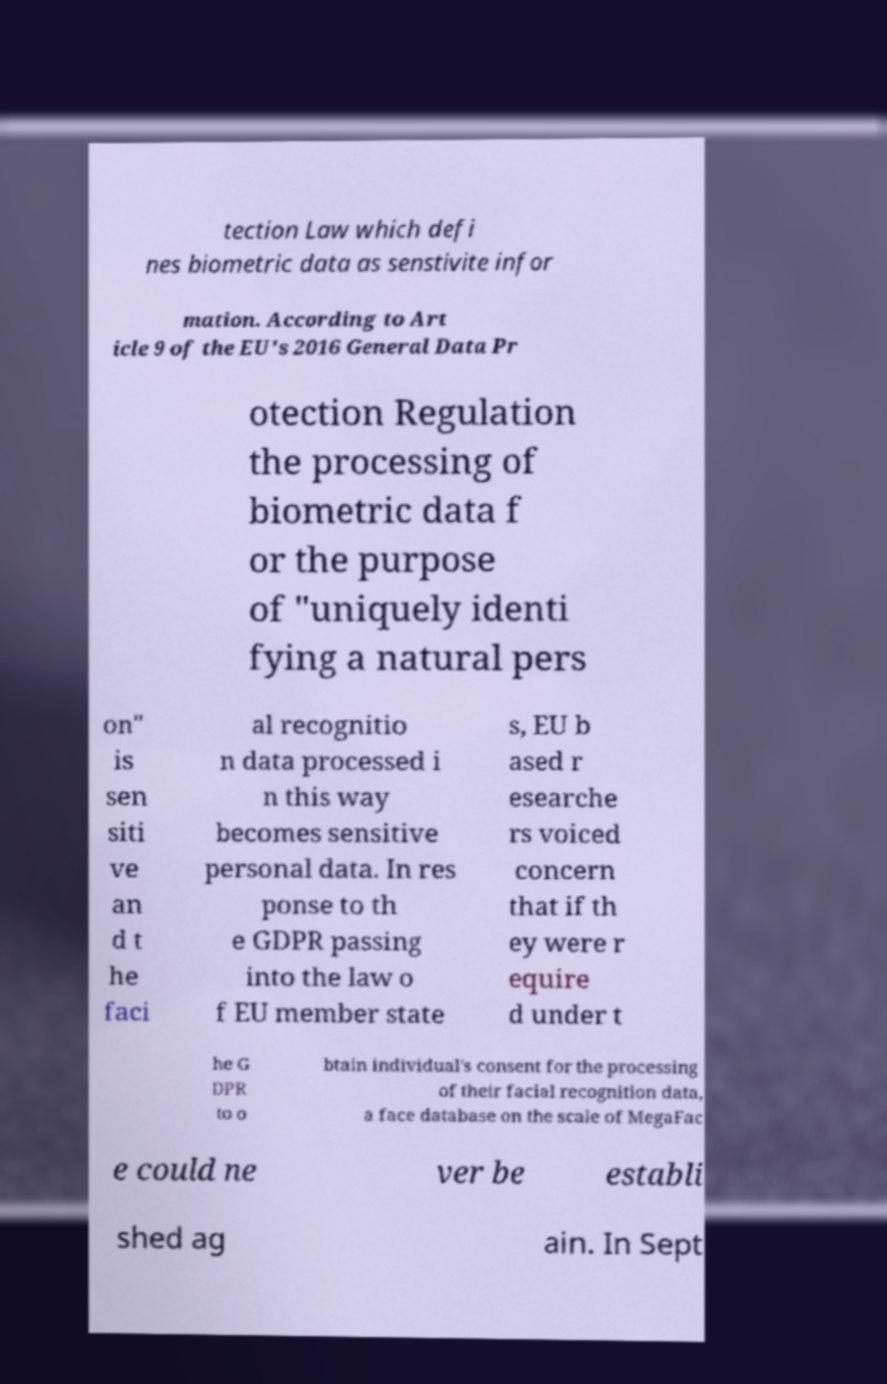What messages or text are displayed in this image? I need them in a readable, typed format. tection Law which defi nes biometric data as senstivite infor mation. According to Art icle 9 of the EU's 2016 General Data Pr otection Regulation the processing of biometric data f or the purpose of "uniquely identi fying a natural pers on" is sen siti ve an d t he faci al recognitio n data processed i n this way becomes sensitive personal data. In res ponse to th e GDPR passing into the law o f EU member state s, EU b ased r esearche rs voiced concern that if th ey were r equire d under t he G DPR to o btain individual's consent for the processing of their facial recognition data, a face database on the scale of MegaFac e could ne ver be establi shed ag ain. In Sept 